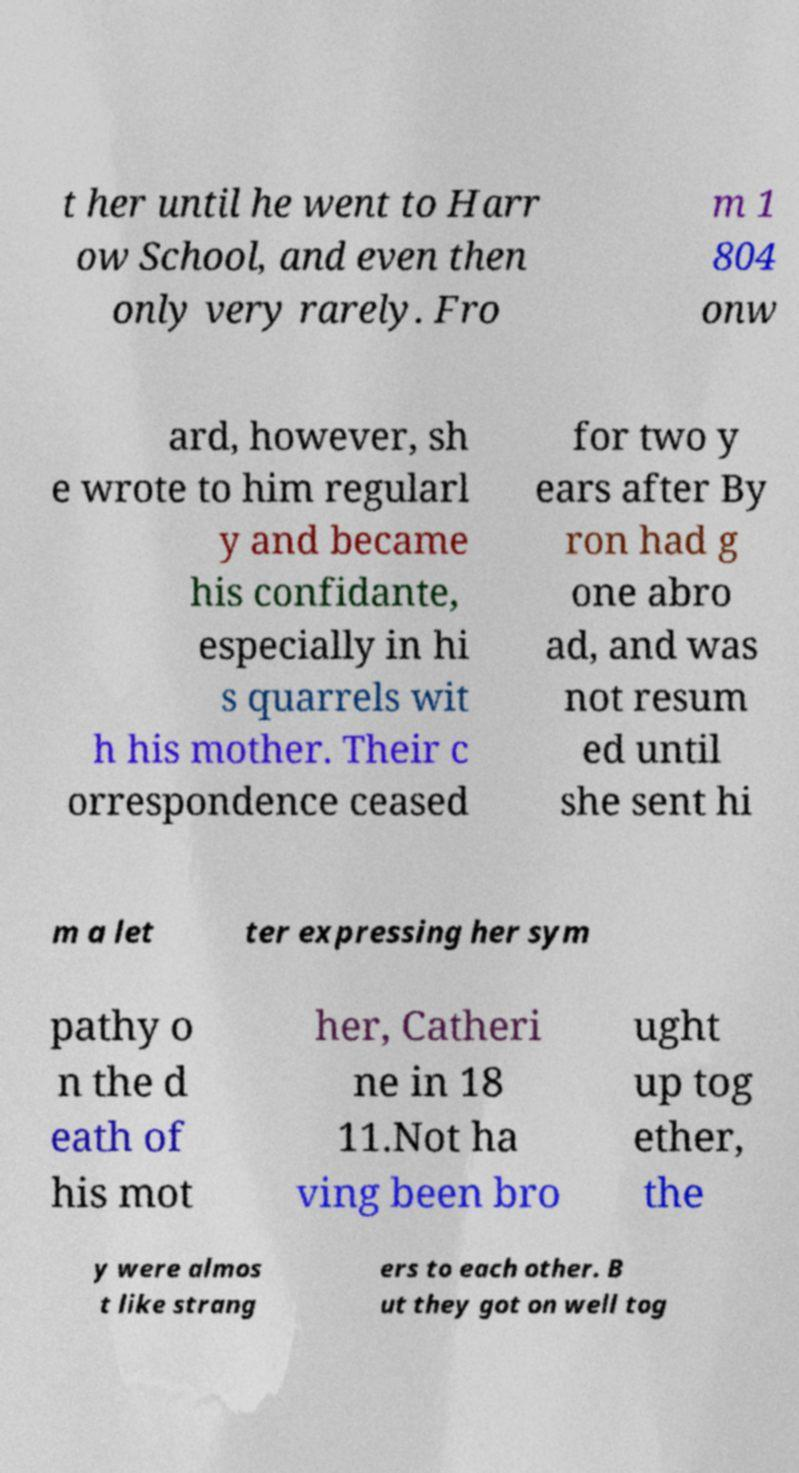I need the written content from this picture converted into text. Can you do that? t her until he went to Harr ow School, and even then only very rarely. Fro m 1 804 onw ard, however, sh e wrote to him regularl y and became his confidante, especially in hi s quarrels wit h his mother. Their c orrespondence ceased for two y ears after By ron had g one abro ad, and was not resum ed until she sent hi m a let ter expressing her sym pathy o n the d eath of his mot her, Catheri ne in 18 11.Not ha ving been bro ught up tog ether, the y were almos t like strang ers to each other. B ut they got on well tog 